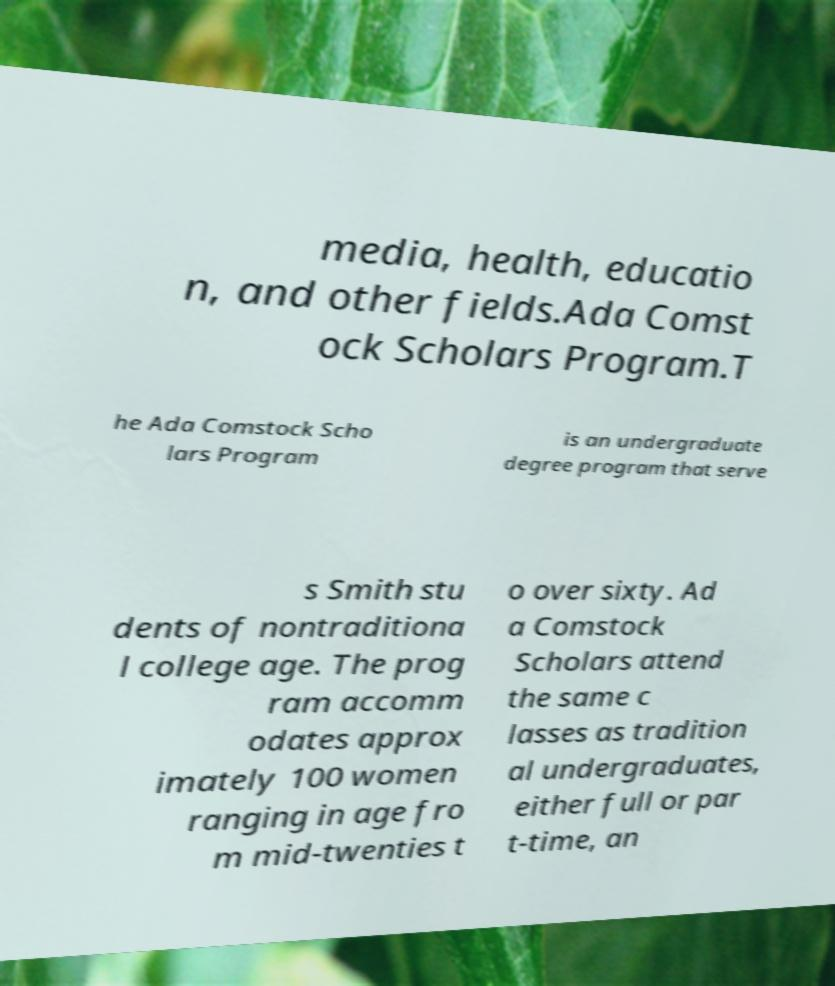What messages or text are displayed in this image? I need them in a readable, typed format. media, health, educatio n, and other fields.Ada Comst ock Scholars Program.T he Ada Comstock Scho lars Program is an undergraduate degree program that serve s Smith stu dents of nontraditiona l college age. The prog ram accomm odates approx imately 100 women ranging in age fro m mid-twenties t o over sixty. Ad a Comstock Scholars attend the same c lasses as tradition al undergraduates, either full or par t-time, an 